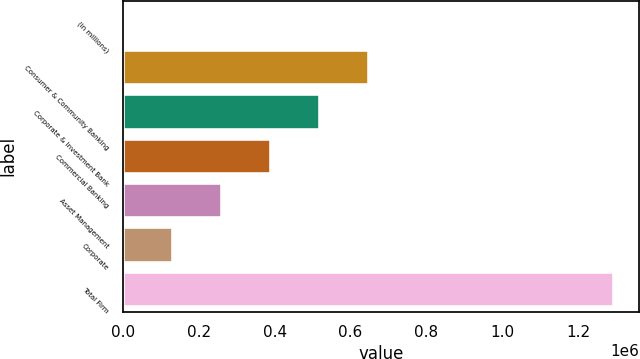Convert chart. <chart><loc_0><loc_0><loc_500><loc_500><bar_chart><fcel>(in millions)<fcel>Consumer & Community Banking<fcel>Corporate & Investment Bank<fcel>Commercial Banking<fcel>Asset Management<fcel>Corporate<fcel>Total Firm<nl><fcel>2015<fcel>648902<fcel>519524<fcel>390147<fcel>260770<fcel>131392<fcel>1.29579e+06<nl></chart> 